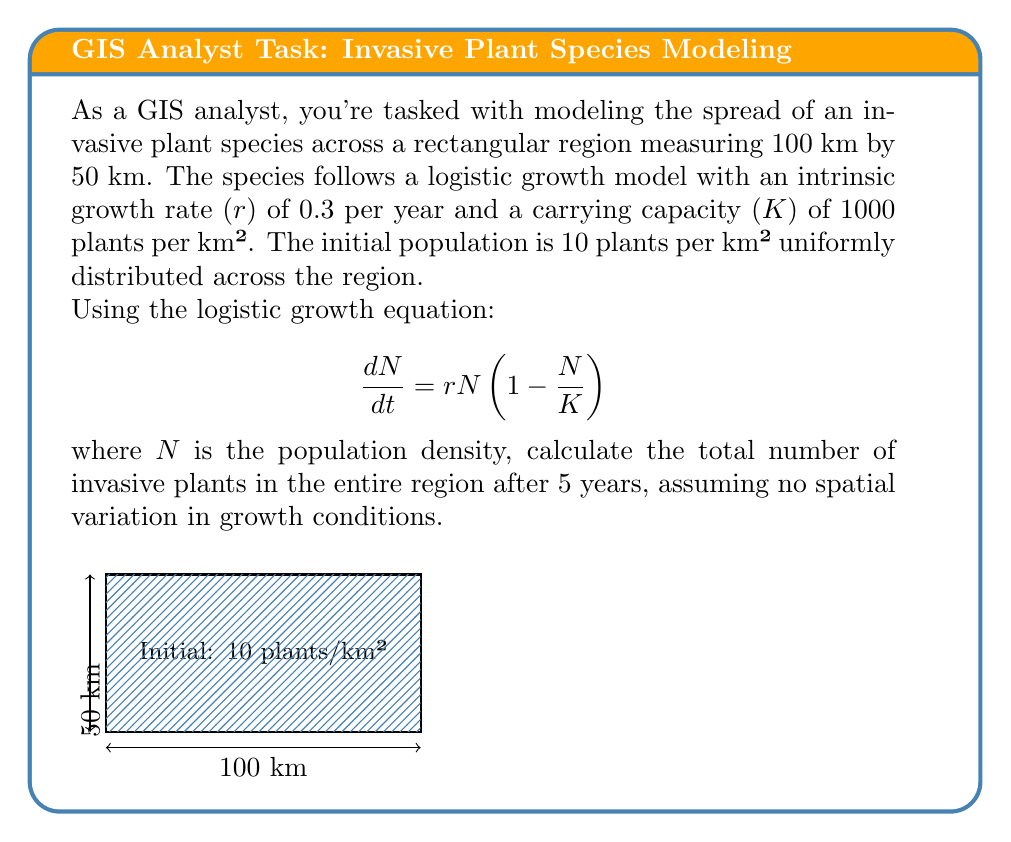Give your solution to this math problem. Let's approach this step-by-step:

1) First, we need to solve the logistic growth equation. The solution to this differential equation is:

   $$ N(t) = \frac{K}{1 + (\frac{K}{N_0} - 1)e^{-rt}} $$

   Where $N_0$ is the initial population density.

2) We're given:
   - $r = 0.3$ per year
   - $K = 1000$ plants per km²
   - $N_0 = 10$ plants per km²
   - $t = 5$ years

3) Let's substitute these values into the equation:

   $$ N(5) = \frac{1000}{1 + (\frac{1000}{10} - 1)e^{-0.3 \cdot 5}} $$

4) Simplify:
   $$ N(5) = \frac{1000}{1 + 99e^{-1.5}} $$

5) Calculate:
   $$ N(5) \approx 201.59 \text{ plants per km²} $$

6) Now, we need to calculate the total area of the region:
   Area = 100 km × 50 km = 5000 km²

7) To get the total number of plants, multiply the density by the area:
   Total plants = 201.59 plants/km² × 5000 km² ≈ 1,007,950 plants
Answer: 1,007,950 plants 